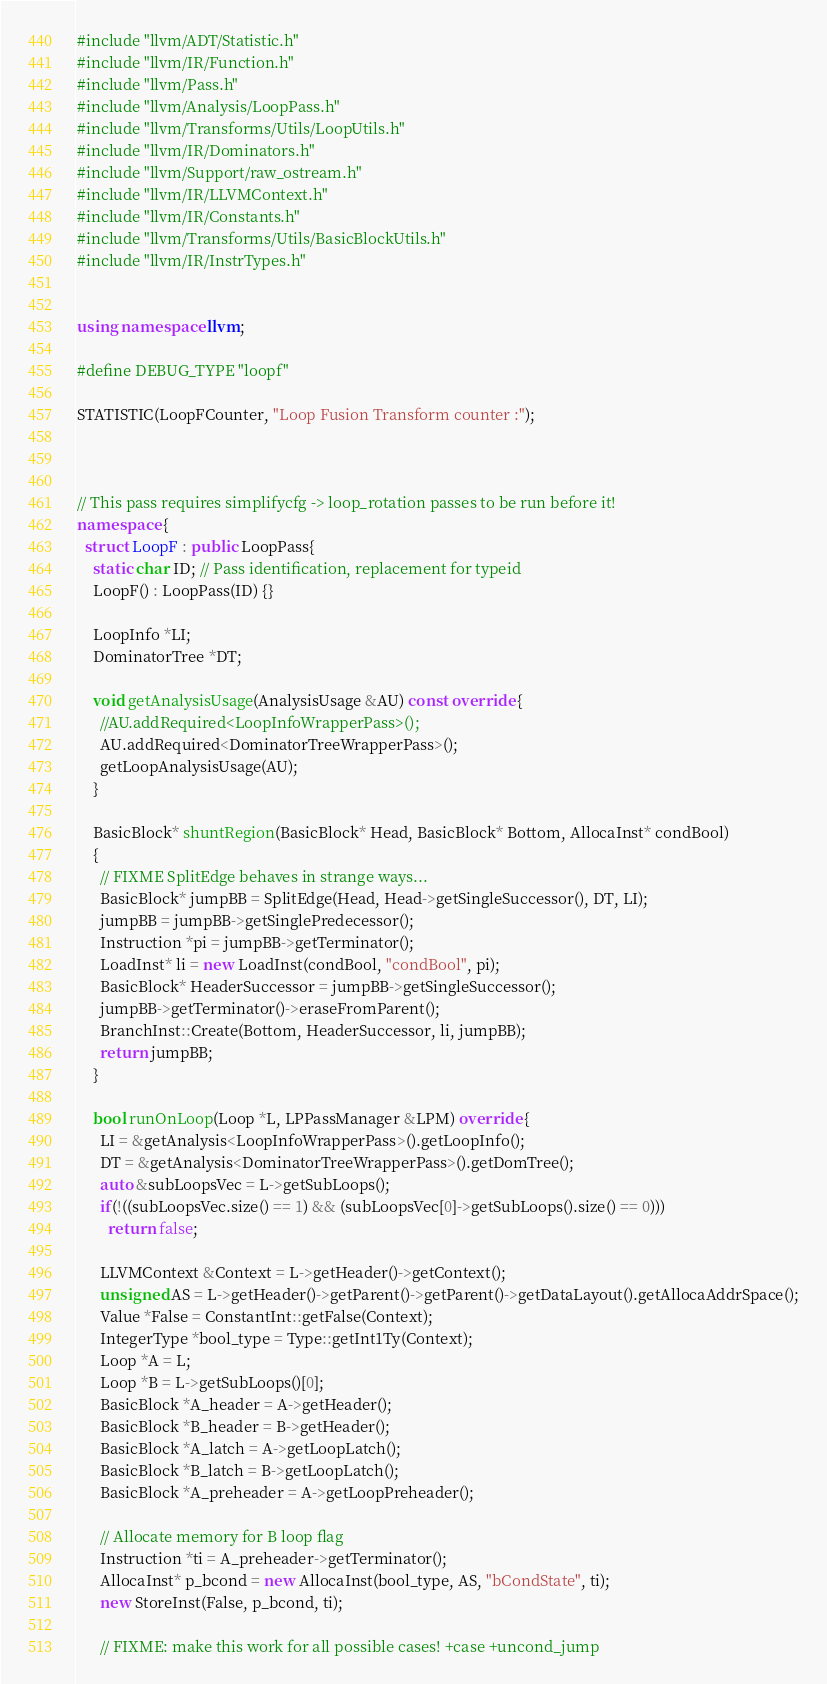<code> <loc_0><loc_0><loc_500><loc_500><_C++_>#include "llvm/ADT/Statistic.h"
#include "llvm/IR/Function.h"
#include "llvm/Pass.h"
#include "llvm/Analysis/LoopPass.h"
#include "llvm/Transforms/Utils/LoopUtils.h"
#include "llvm/IR/Dominators.h"
#include "llvm/Support/raw_ostream.h"
#include "llvm/IR/LLVMContext.h"
#include "llvm/IR/Constants.h"
#include "llvm/Transforms/Utils/BasicBlockUtils.h"
#include "llvm/IR/InstrTypes.h"


using namespace llvm;

#define DEBUG_TYPE "loopf"

STATISTIC(LoopFCounter, "Loop Fusion Transform counter :");



// This pass requires simplifycfg -> loop_rotation passes to be run before it!
namespace {
  struct LoopF : public LoopPass{
    static char ID; // Pass identification, replacement for typeid
    LoopF() : LoopPass(ID) {}

    LoopInfo *LI;
    DominatorTree *DT;

    void getAnalysisUsage(AnalysisUsage &AU) const override {
      //AU.addRequired<LoopInfoWrapperPass>();
      AU.addRequired<DominatorTreeWrapperPass>();
      getLoopAnalysisUsage(AU);
    }

    BasicBlock* shuntRegion(BasicBlock* Head, BasicBlock* Bottom, AllocaInst* condBool)
    {
      // FIXME SplitEdge behaves in strange ways...
      BasicBlock* jumpBB = SplitEdge(Head, Head->getSingleSuccessor(), DT, LI);
      jumpBB = jumpBB->getSinglePredecessor();
      Instruction *pi = jumpBB->getTerminator();
      LoadInst* li = new LoadInst(condBool, "condBool", pi);
      BasicBlock* HeaderSuccessor = jumpBB->getSingleSuccessor();
      jumpBB->getTerminator()->eraseFromParent();
      BranchInst::Create(Bottom, HeaderSuccessor, li, jumpBB);
      return jumpBB;
    }

    bool runOnLoop(Loop *L, LPPassManager &LPM) override {
      LI = &getAnalysis<LoopInfoWrapperPass>().getLoopInfo();
      DT = &getAnalysis<DominatorTreeWrapperPass>().getDomTree();
      auto &subLoopsVec = L->getSubLoops();
      if(!((subLoopsVec.size() == 1) && (subLoopsVec[0]->getSubLoops().size() == 0)))
        return false;

      LLVMContext &Context = L->getHeader()->getContext();
      unsigned AS = L->getHeader()->getParent()->getParent()->getDataLayout().getAllocaAddrSpace();
      Value *False = ConstantInt::getFalse(Context);
      IntegerType *bool_type = Type::getInt1Ty(Context);
      Loop *A = L;
      Loop *B = L->getSubLoops()[0];
      BasicBlock *A_header = A->getHeader();
      BasicBlock *B_header = B->getHeader();
      BasicBlock *A_latch = A->getLoopLatch();
      BasicBlock *B_latch = B->getLoopLatch();
      BasicBlock *A_preheader = A->getLoopPreheader();

      // Allocate memory for B loop flag
      Instruction *ti = A_preheader->getTerminator();
      AllocaInst* p_bcond = new AllocaInst(bool_type, AS, "bCondState", ti);
      new StoreInst(False, p_bcond, ti);

      // FIXME: make this work for all possible cases! +case +uncond_jump</code> 